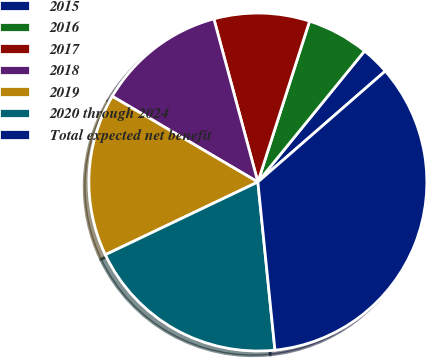Convert chart to OTSL. <chart><loc_0><loc_0><loc_500><loc_500><pie_chart><fcel>2015<fcel>2016<fcel>2017<fcel>2018<fcel>2019<fcel>2020 through 2024<fcel>Total expected net benefit<nl><fcel>2.72%<fcel>5.93%<fcel>9.14%<fcel>12.34%<fcel>15.55%<fcel>19.53%<fcel>34.79%<nl></chart> 